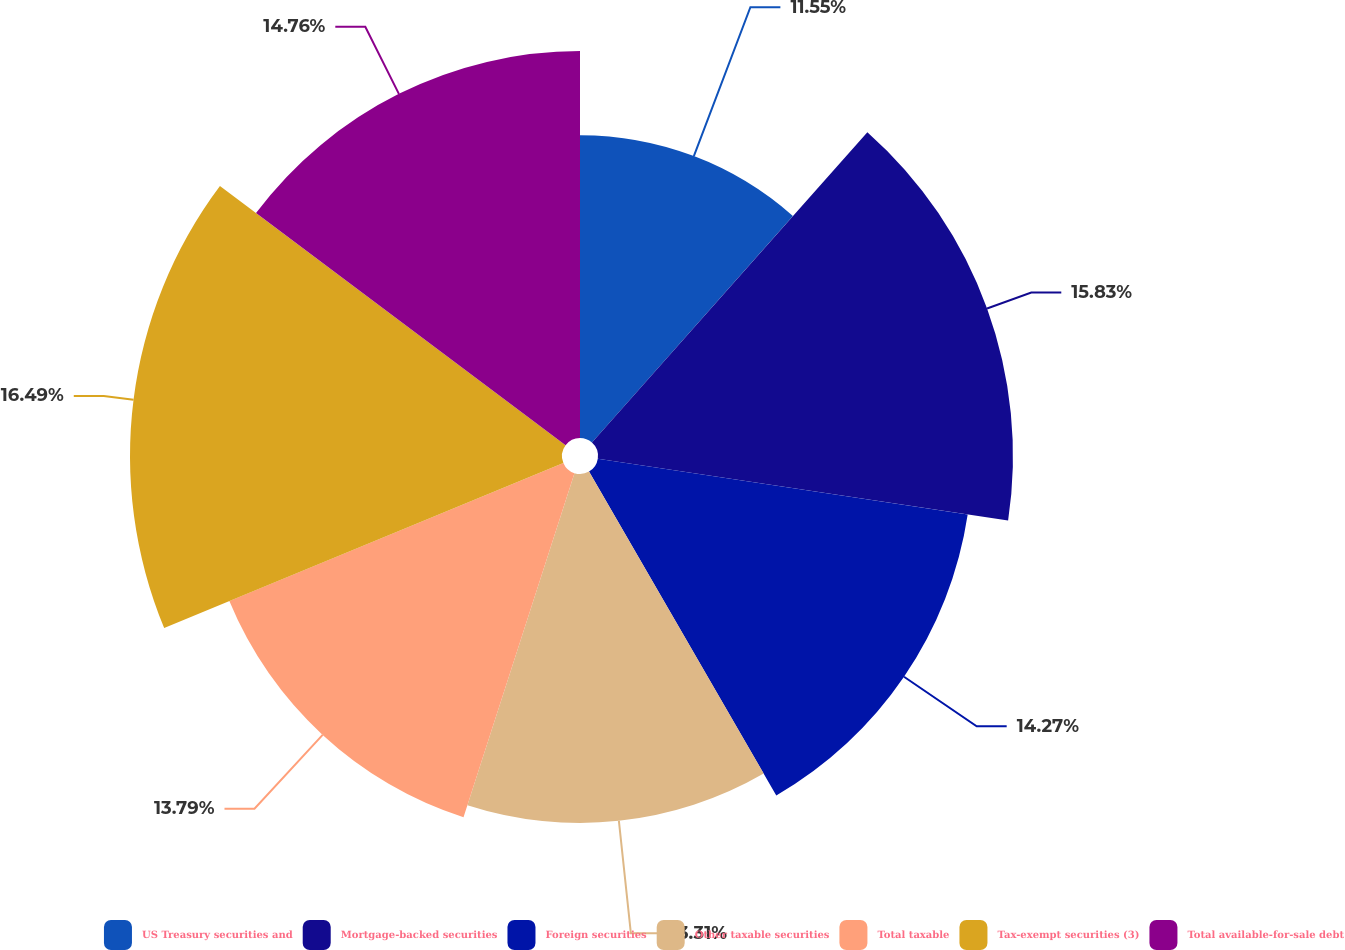<chart> <loc_0><loc_0><loc_500><loc_500><pie_chart><fcel>US Treasury securities and<fcel>Mortgage-backed securities<fcel>Foreign securities<fcel>Other taxable securities<fcel>Total taxable<fcel>Tax-exempt securities (3)<fcel>Total available-for-sale debt<nl><fcel>11.55%<fcel>15.83%<fcel>14.27%<fcel>13.31%<fcel>13.79%<fcel>16.48%<fcel>14.76%<nl></chart> 